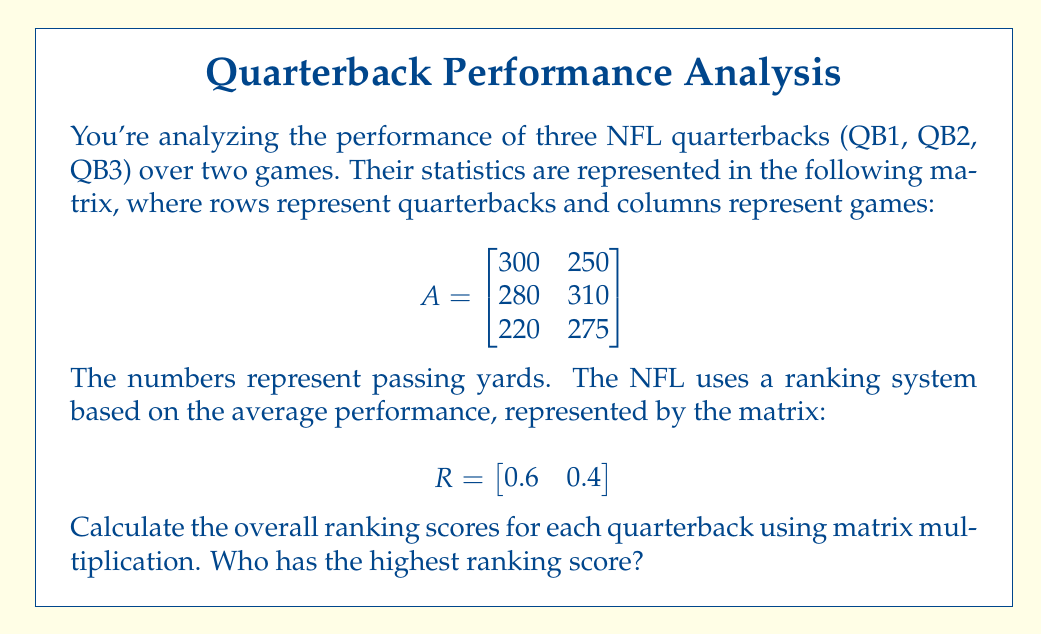Solve this math problem. To solve this problem, we need to multiply matrix A by the transpose of matrix R. This will give us a column vector with the weighted average (ranking score) for each quarterback.

Step 1: Transpose matrix R
$$R^T = \begin{bmatrix}
0.6 \\
0.4
\end{bmatrix}$$

Step 2: Multiply A by R^T
$$AR^T = \begin{bmatrix}
300 & 250 \\
280 & 310 \\
220 & 275
\end{bmatrix} \times \begin{bmatrix}
0.6 \\
0.4
\end{bmatrix}$$

Step 3: Perform the matrix multiplication
For QB1: $(300 \times 0.6) + (250 \times 0.4) = 180 + 100 = 280$
For QB2: $(280 \times 0.6) + (310 \times 0.4) = 168 + 124 = 292$
For QB3: $(220 \times 0.6) + (275 \times 0.4) = 132 + 110 = 242$

The result is:
$$AR^T = \begin{bmatrix}
280 \\
292 \\
242
\end{bmatrix}$$

Step 4: Compare the scores
QB1: 280
QB2: 292
QB3: 242

QB2 has the highest ranking score of 292.
Answer: QB2 